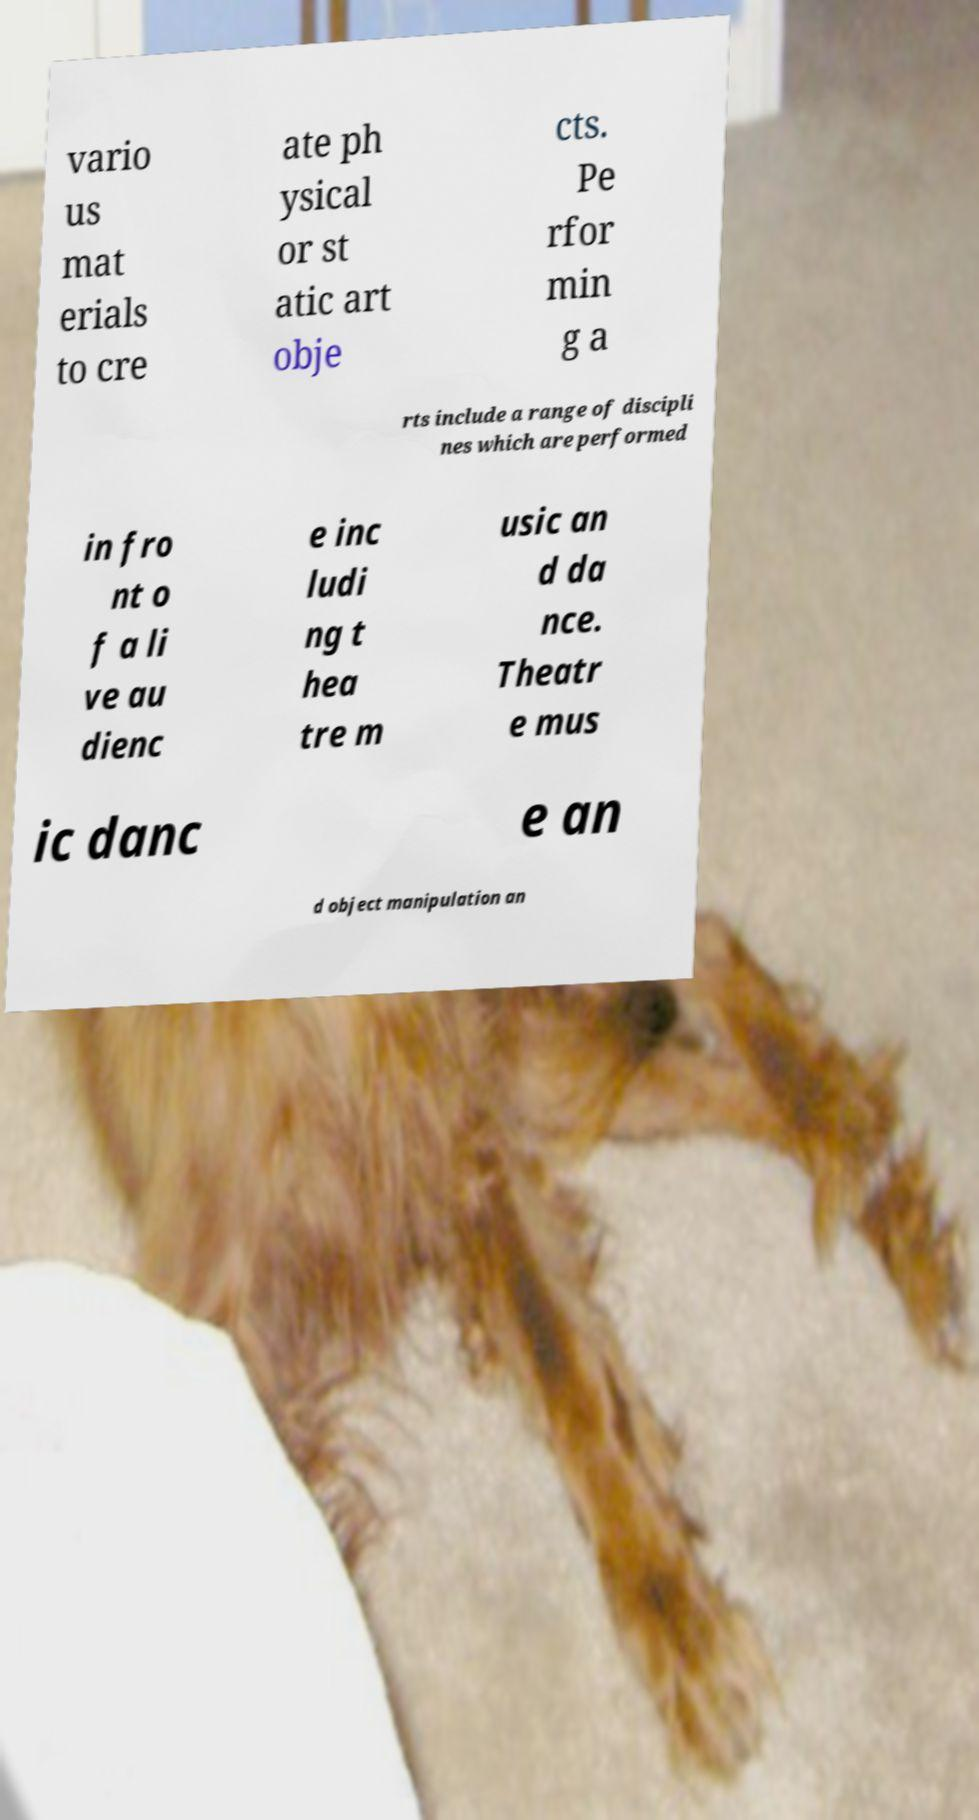Can you accurately transcribe the text from the provided image for me? vario us mat erials to cre ate ph ysical or st atic art obje cts. Pe rfor min g a rts include a range of discipli nes which are performed in fro nt o f a li ve au dienc e inc ludi ng t hea tre m usic an d da nce. Theatr e mus ic danc e an d object manipulation an 